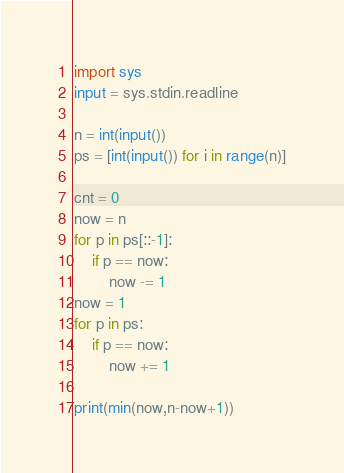Convert code to text. <code><loc_0><loc_0><loc_500><loc_500><_Python_>import sys
input = sys.stdin.readline

n = int(input())
ps = [int(input()) for i in range(n)]

cnt = 0
now = n
for p in ps[::-1]:
    if p == now:
        now -= 1
now = 1
for p in ps:
    if p == now:
        now += 1

print(min(now,n-now+1))
</code> 